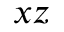<formula> <loc_0><loc_0><loc_500><loc_500>x z</formula> 